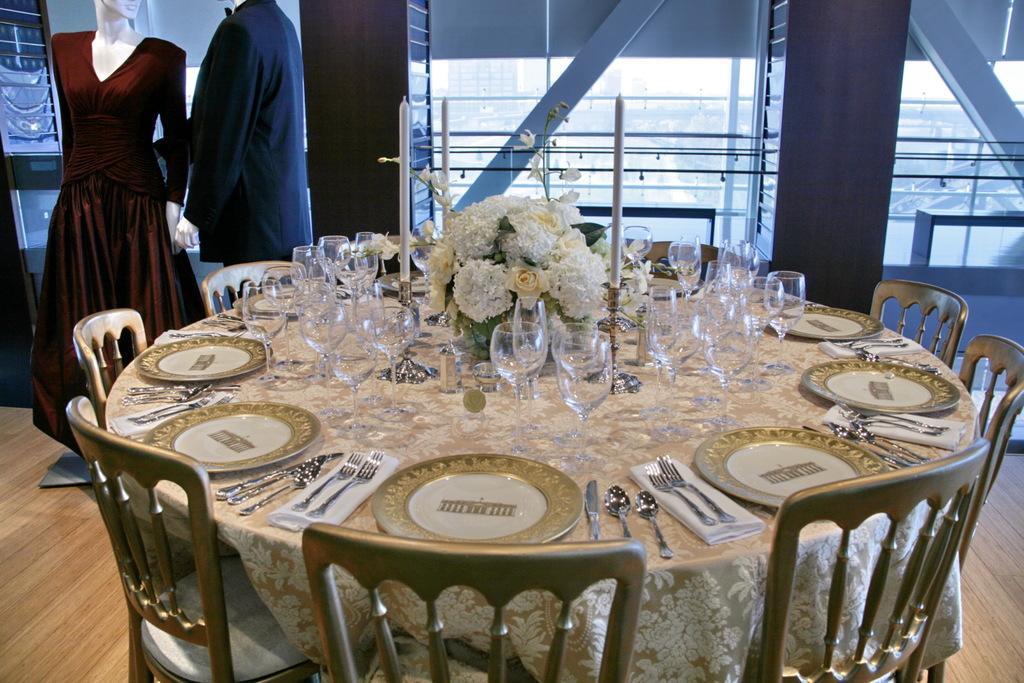Describe this image in one or two sentences. As we can see in the image there are chairs, two toys and a table. On table there are bouquet, glasses, plates, forks, knives and spoons. 